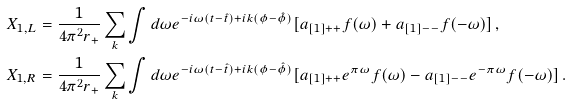Convert formula to latex. <formula><loc_0><loc_0><loc_500><loc_500>X _ { 1 , L } & = \frac { 1 } { 4 \pi ^ { 2 } r _ { + } } \sum _ { k } \int d \omega e ^ { - i \omega ( t - \hat { t } ) + i k ( \phi - \hat { \phi } ) } [ a _ { [ 1 ] + + } f ( \omega ) + a _ { [ 1 ] - - } f ( - \omega ) ] \, , \\ X _ { 1 , R } & = \frac { 1 } { 4 \pi ^ { 2 } r _ { + } } \sum _ { k } \int d \omega e ^ { - i \omega ( t - \hat { t } ) + i k ( \phi - \hat { \phi } ) } [ a _ { [ 1 ] + + } e ^ { \pi \omega } f ( \omega ) - a _ { [ 1 ] - - } e ^ { - \pi \omega } f ( - \omega ) ] \, .</formula> 